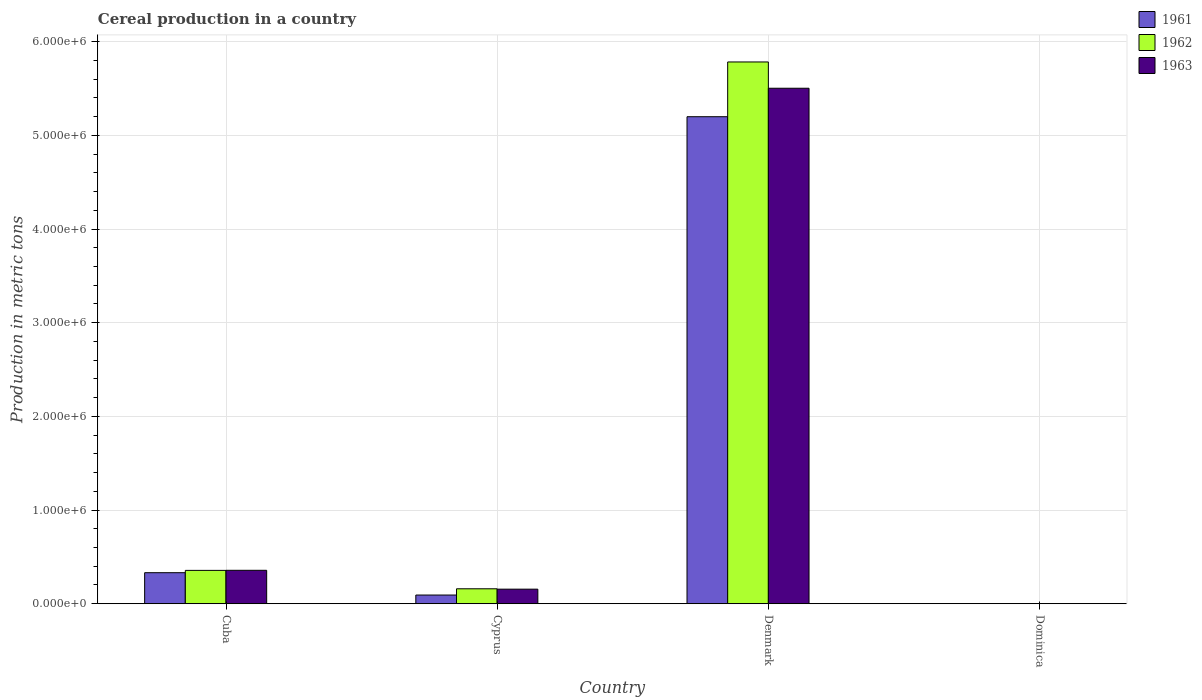How many different coloured bars are there?
Make the answer very short. 3. Are the number of bars on each tick of the X-axis equal?
Offer a very short reply. Yes. How many bars are there on the 1st tick from the left?
Provide a short and direct response. 3. How many bars are there on the 4th tick from the right?
Ensure brevity in your answer.  3. What is the label of the 2nd group of bars from the left?
Provide a short and direct response. Cyprus. In how many cases, is the number of bars for a given country not equal to the number of legend labels?
Provide a short and direct response. 0. What is the total cereal production in 1962 in Cuba?
Your answer should be very brief. 3.56e+05. Across all countries, what is the maximum total cereal production in 1963?
Provide a succinct answer. 5.50e+06. Across all countries, what is the minimum total cereal production in 1962?
Offer a terse response. 130. In which country was the total cereal production in 1961 maximum?
Your answer should be compact. Denmark. In which country was the total cereal production in 1963 minimum?
Give a very brief answer. Dominica. What is the total total cereal production in 1962 in the graph?
Offer a terse response. 6.30e+06. What is the difference between the total cereal production in 1963 in Cyprus and that in Denmark?
Ensure brevity in your answer.  -5.35e+06. What is the difference between the total cereal production in 1963 in Cyprus and the total cereal production in 1962 in Cuba?
Provide a succinct answer. -2.00e+05. What is the average total cereal production in 1962 per country?
Your answer should be compact. 1.57e+06. What is the difference between the total cereal production of/in 1962 and total cereal production of/in 1961 in Cyprus?
Your answer should be compact. 6.68e+04. What is the ratio of the total cereal production in 1961 in Cyprus to that in Dominica?
Offer a very short reply. 713.55. Is the difference between the total cereal production in 1962 in Cuba and Cyprus greater than the difference between the total cereal production in 1961 in Cuba and Cyprus?
Provide a succinct answer. No. What is the difference between the highest and the second highest total cereal production in 1962?
Give a very brief answer. -5.62e+06. What is the difference between the highest and the lowest total cereal production in 1962?
Ensure brevity in your answer.  5.78e+06. In how many countries, is the total cereal production in 1963 greater than the average total cereal production in 1963 taken over all countries?
Provide a succinct answer. 1. What does the 3rd bar from the left in Denmark represents?
Give a very brief answer. 1963. What is the difference between two consecutive major ticks on the Y-axis?
Provide a succinct answer. 1.00e+06. Does the graph contain grids?
Offer a terse response. Yes. Where does the legend appear in the graph?
Offer a very short reply. Top right. How many legend labels are there?
Your answer should be compact. 3. What is the title of the graph?
Ensure brevity in your answer.  Cereal production in a country. Does "1973" appear as one of the legend labels in the graph?
Your answer should be compact. No. What is the label or title of the X-axis?
Ensure brevity in your answer.  Country. What is the label or title of the Y-axis?
Provide a short and direct response. Production in metric tons. What is the Production in metric tons in 1961 in Cuba?
Provide a succinct answer. 3.31e+05. What is the Production in metric tons of 1962 in Cuba?
Your answer should be very brief. 3.56e+05. What is the Production in metric tons in 1963 in Cuba?
Provide a succinct answer. 3.57e+05. What is the Production in metric tons of 1961 in Cyprus?
Offer a terse response. 9.28e+04. What is the Production in metric tons of 1962 in Cyprus?
Your answer should be very brief. 1.60e+05. What is the Production in metric tons in 1963 in Cyprus?
Provide a succinct answer. 1.56e+05. What is the Production in metric tons in 1961 in Denmark?
Provide a short and direct response. 5.20e+06. What is the Production in metric tons in 1962 in Denmark?
Provide a short and direct response. 5.78e+06. What is the Production in metric tons of 1963 in Denmark?
Your answer should be very brief. 5.50e+06. What is the Production in metric tons of 1961 in Dominica?
Your response must be concise. 130. What is the Production in metric tons of 1962 in Dominica?
Make the answer very short. 130. What is the Production in metric tons in 1963 in Dominica?
Offer a very short reply. 140. Across all countries, what is the maximum Production in metric tons in 1961?
Keep it short and to the point. 5.20e+06. Across all countries, what is the maximum Production in metric tons in 1962?
Make the answer very short. 5.78e+06. Across all countries, what is the maximum Production in metric tons of 1963?
Your answer should be very brief. 5.50e+06. Across all countries, what is the minimum Production in metric tons in 1961?
Ensure brevity in your answer.  130. Across all countries, what is the minimum Production in metric tons in 1962?
Provide a succinct answer. 130. Across all countries, what is the minimum Production in metric tons in 1963?
Ensure brevity in your answer.  140. What is the total Production in metric tons of 1961 in the graph?
Offer a terse response. 5.62e+06. What is the total Production in metric tons of 1962 in the graph?
Offer a very short reply. 6.30e+06. What is the total Production in metric tons in 1963 in the graph?
Your response must be concise. 6.02e+06. What is the difference between the Production in metric tons of 1961 in Cuba and that in Cyprus?
Offer a very short reply. 2.39e+05. What is the difference between the Production in metric tons of 1962 in Cuba and that in Cyprus?
Your response must be concise. 1.97e+05. What is the difference between the Production in metric tons of 1963 in Cuba and that in Cyprus?
Your response must be concise. 2.01e+05. What is the difference between the Production in metric tons in 1961 in Cuba and that in Denmark?
Your answer should be very brief. -4.87e+06. What is the difference between the Production in metric tons of 1962 in Cuba and that in Denmark?
Make the answer very short. -5.43e+06. What is the difference between the Production in metric tons of 1963 in Cuba and that in Denmark?
Your answer should be compact. -5.15e+06. What is the difference between the Production in metric tons in 1961 in Cuba and that in Dominica?
Offer a terse response. 3.31e+05. What is the difference between the Production in metric tons in 1962 in Cuba and that in Dominica?
Offer a terse response. 3.56e+05. What is the difference between the Production in metric tons in 1963 in Cuba and that in Dominica?
Provide a succinct answer. 3.57e+05. What is the difference between the Production in metric tons of 1961 in Cyprus and that in Denmark?
Offer a very short reply. -5.11e+06. What is the difference between the Production in metric tons in 1962 in Cyprus and that in Denmark?
Offer a terse response. -5.62e+06. What is the difference between the Production in metric tons of 1963 in Cyprus and that in Denmark?
Offer a very short reply. -5.35e+06. What is the difference between the Production in metric tons in 1961 in Cyprus and that in Dominica?
Offer a very short reply. 9.26e+04. What is the difference between the Production in metric tons in 1962 in Cyprus and that in Dominica?
Give a very brief answer. 1.59e+05. What is the difference between the Production in metric tons of 1963 in Cyprus and that in Dominica?
Offer a very short reply. 1.55e+05. What is the difference between the Production in metric tons of 1961 in Denmark and that in Dominica?
Keep it short and to the point. 5.20e+06. What is the difference between the Production in metric tons in 1962 in Denmark and that in Dominica?
Provide a succinct answer. 5.78e+06. What is the difference between the Production in metric tons of 1963 in Denmark and that in Dominica?
Provide a short and direct response. 5.50e+06. What is the difference between the Production in metric tons of 1961 in Cuba and the Production in metric tons of 1962 in Cyprus?
Offer a very short reply. 1.72e+05. What is the difference between the Production in metric tons in 1961 in Cuba and the Production in metric tons in 1963 in Cyprus?
Offer a terse response. 1.76e+05. What is the difference between the Production in metric tons in 1962 in Cuba and the Production in metric tons in 1963 in Cyprus?
Ensure brevity in your answer.  2.00e+05. What is the difference between the Production in metric tons of 1961 in Cuba and the Production in metric tons of 1962 in Denmark?
Offer a terse response. -5.45e+06. What is the difference between the Production in metric tons of 1961 in Cuba and the Production in metric tons of 1963 in Denmark?
Provide a short and direct response. -5.17e+06. What is the difference between the Production in metric tons in 1962 in Cuba and the Production in metric tons in 1963 in Denmark?
Offer a very short reply. -5.15e+06. What is the difference between the Production in metric tons of 1961 in Cuba and the Production in metric tons of 1962 in Dominica?
Provide a short and direct response. 3.31e+05. What is the difference between the Production in metric tons of 1961 in Cuba and the Production in metric tons of 1963 in Dominica?
Provide a succinct answer. 3.31e+05. What is the difference between the Production in metric tons in 1962 in Cuba and the Production in metric tons in 1963 in Dominica?
Provide a short and direct response. 3.56e+05. What is the difference between the Production in metric tons of 1961 in Cyprus and the Production in metric tons of 1962 in Denmark?
Your answer should be very brief. -5.69e+06. What is the difference between the Production in metric tons of 1961 in Cyprus and the Production in metric tons of 1963 in Denmark?
Give a very brief answer. -5.41e+06. What is the difference between the Production in metric tons of 1962 in Cyprus and the Production in metric tons of 1963 in Denmark?
Provide a short and direct response. -5.34e+06. What is the difference between the Production in metric tons of 1961 in Cyprus and the Production in metric tons of 1962 in Dominica?
Provide a succinct answer. 9.26e+04. What is the difference between the Production in metric tons in 1961 in Cyprus and the Production in metric tons in 1963 in Dominica?
Keep it short and to the point. 9.26e+04. What is the difference between the Production in metric tons of 1962 in Cyprus and the Production in metric tons of 1963 in Dominica?
Give a very brief answer. 1.59e+05. What is the difference between the Production in metric tons in 1961 in Denmark and the Production in metric tons in 1962 in Dominica?
Give a very brief answer. 5.20e+06. What is the difference between the Production in metric tons of 1961 in Denmark and the Production in metric tons of 1963 in Dominica?
Your answer should be compact. 5.20e+06. What is the difference between the Production in metric tons in 1962 in Denmark and the Production in metric tons in 1963 in Dominica?
Provide a succinct answer. 5.78e+06. What is the average Production in metric tons of 1961 per country?
Provide a succinct answer. 1.41e+06. What is the average Production in metric tons of 1962 per country?
Your response must be concise. 1.57e+06. What is the average Production in metric tons of 1963 per country?
Offer a very short reply. 1.50e+06. What is the difference between the Production in metric tons of 1961 and Production in metric tons of 1962 in Cuba?
Make the answer very short. -2.47e+04. What is the difference between the Production in metric tons in 1961 and Production in metric tons in 1963 in Cuba?
Your answer should be compact. -2.56e+04. What is the difference between the Production in metric tons of 1962 and Production in metric tons of 1963 in Cuba?
Provide a succinct answer. -880. What is the difference between the Production in metric tons in 1961 and Production in metric tons in 1962 in Cyprus?
Your answer should be compact. -6.68e+04. What is the difference between the Production in metric tons in 1961 and Production in metric tons in 1963 in Cyprus?
Offer a very short reply. -6.28e+04. What is the difference between the Production in metric tons of 1962 and Production in metric tons of 1963 in Cyprus?
Offer a very short reply. 3950. What is the difference between the Production in metric tons in 1961 and Production in metric tons in 1962 in Denmark?
Give a very brief answer. -5.85e+05. What is the difference between the Production in metric tons of 1961 and Production in metric tons of 1963 in Denmark?
Your answer should be compact. -3.04e+05. What is the difference between the Production in metric tons in 1962 and Production in metric tons in 1963 in Denmark?
Your answer should be very brief. 2.80e+05. What is the ratio of the Production in metric tons in 1961 in Cuba to that in Cyprus?
Your response must be concise. 3.57. What is the ratio of the Production in metric tons in 1962 in Cuba to that in Cyprus?
Keep it short and to the point. 2.23. What is the ratio of the Production in metric tons of 1963 in Cuba to that in Cyprus?
Your answer should be very brief. 2.29. What is the ratio of the Production in metric tons in 1961 in Cuba to that in Denmark?
Your response must be concise. 0.06. What is the ratio of the Production in metric tons in 1962 in Cuba to that in Denmark?
Ensure brevity in your answer.  0.06. What is the ratio of the Production in metric tons in 1963 in Cuba to that in Denmark?
Ensure brevity in your answer.  0.06. What is the ratio of the Production in metric tons in 1961 in Cuba to that in Dominica?
Offer a terse response. 2548.52. What is the ratio of the Production in metric tons of 1962 in Cuba to that in Dominica?
Your answer should be compact. 2738.62. What is the ratio of the Production in metric tons in 1963 in Cuba to that in Dominica?
Keep it short and to the point. 2549.29. What is the ratio of the Production in metric tons of 1961 in Cyprus to that in Denmark?
Ensure brevity in your answer.  0.02. What is the ratio of the Production in metric tons of 1962 in Cyprus to that in Denmark?
Give a very brief answer. 0.03. What is the ratio of the Production in metric tons of 1963 in Cyprus to that in Denmark?
Offer a terse response. 0.03. What is the ratio of the Production in metric tons in 1961 in Cyprus to that in Dominica?
Your response must be concise. 713.55. What is the ratio of the Production in metric tons in 1962 in Cyprus to that in Dominica?
Offer a terse response. 1227.02. What is the ratio of the Production in metric tons of 1963 in Cyprus to that in Dominica?
Make the answer very short. 1111.16. What is the ratio of the Production in metric tons in 1961 in Denmark to that in Dominica?
Provide a succinct answer. 4.00e+04. What is the ratio of the Production in metric tons in 1962 in Denmark to that in Dominica?
Your answer should be compact. 4.45e+04. What is the ratio of the Production in metric tons in 1963 in Denmark to that in Dominica?
Your response must be concise. 3.93e+04. What is the difference between the highest and the second highest Production in metric tons of 1961?
Keep it short and to the point. 4.87e+06. What is the difference between the highest and the second highest Production in metric tons of 1962?
Your answer should be compact. 5.43e+06. What is the difference between the highest and the second highest Production in metric tons of 1963?
Ensure brevity in your answer.  5.15e+06. What is the difference between the highest and the lowest Production in metric tons in 1961?
Your answer should be very brief. 5.20e+06. What is the difference between the highest and the lowest Production in metric tons in 1962?
Give a very brief answer. 5.78e+06. What is the difference between the highest and the lowest Production in metric tons in 1963?
Give a very brief answer. 5.50e+06. 